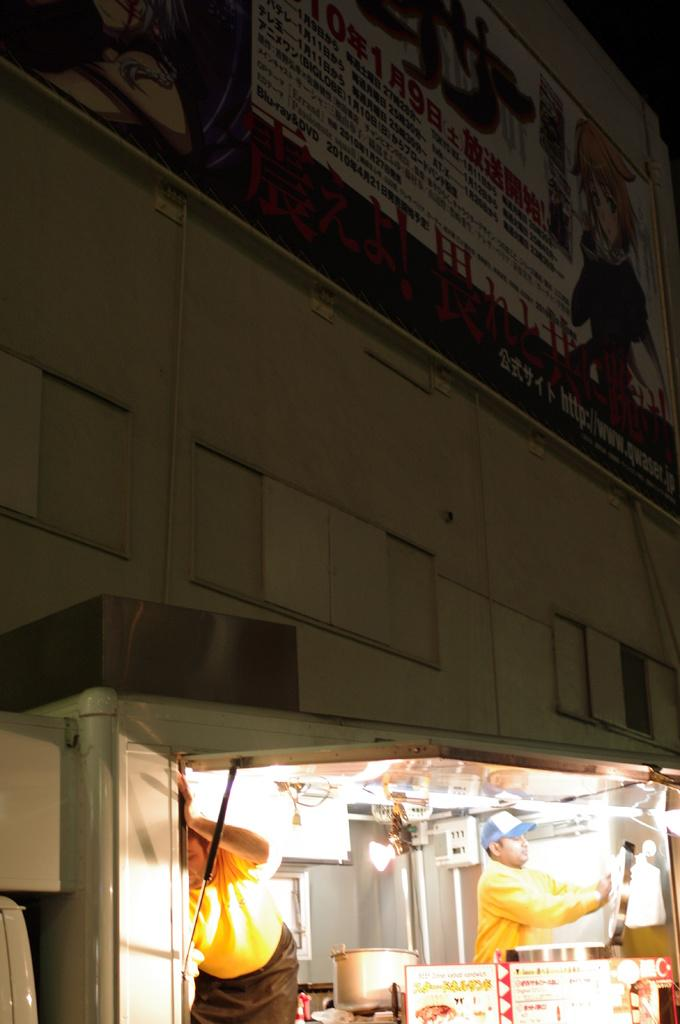How many people are in the image? There are two people in the image. What is in the image besides the people? There is a bowl, posters, lights, some objects, and a banner on the wall in the background of the image. What type of drain can be seen in the image? There is no drain present in the image. What thoughts are the people in the image having? We cannot determine the thoughts of the people in the image based on the provided facts. 